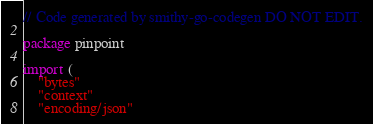<code> <loc_0><loc_0><loc_500><loc_500><_Go_>// Code generated by smithy-go-codegen DO NOT EDIT.

package pinpoint

import (
	"bytes"
	"context"
	"encoding/json"</code> 